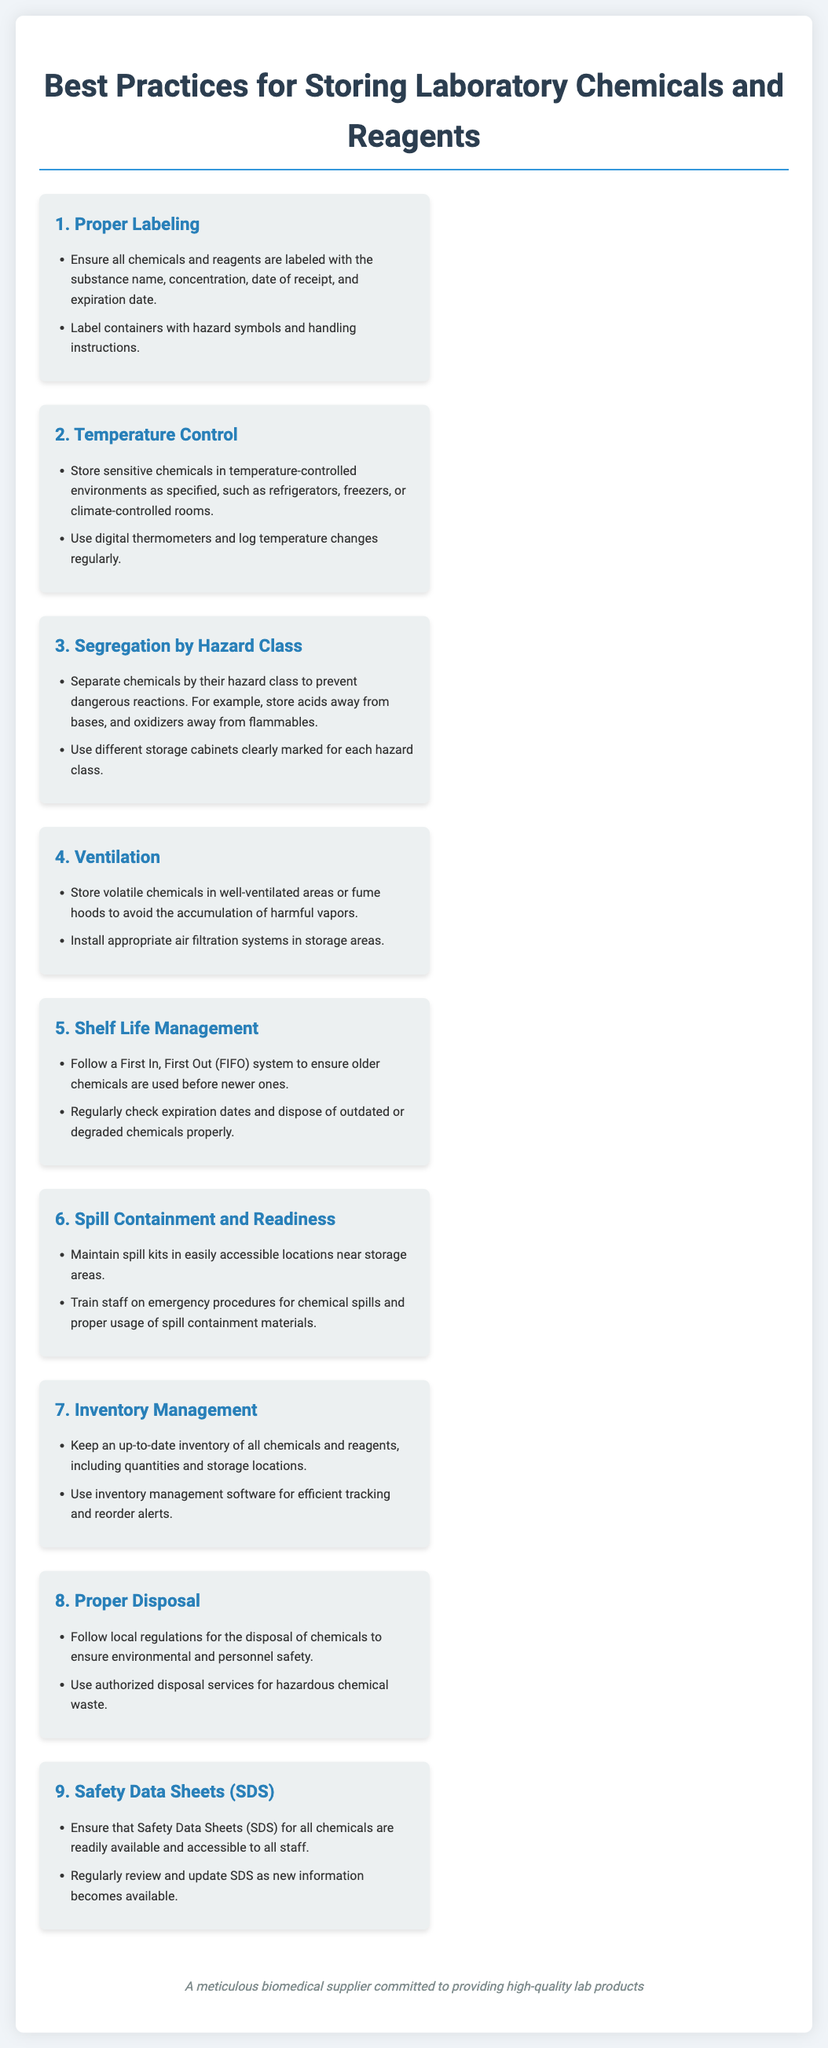What is the first best practice listed? The first best practice in the list is focused on proper labeling of chemicals and reagents.
Answer: Proper Labeling What should volatile chemicals be stored in? The document specifies that volatile chemicals should be stored in well-ventilated areas or fume hoods.
Answer: Well-ventilated areas or fume hoods How often should temperature changes be logged? The document implies that temperature changes should be logged regularly to monitor storage conditions.
Answer: Regularly What storage system is recommended for managing shelf life? The recommended system in the document for managing shelf life is the First In, First Out (FIFO) system.
Answer: First In, First Out (FIFO) Which types of chemicals should be stored separately? Chemicals should be segregated by hazard class to prevent dangerous reactions, such as acids away from bases.
Answer: Hazard class What should be available for all chemicals? The document states that Safety Data Sheets (SDS) should be readily available for all chemicals.
Answer: Safety Data Sheets (SDS) What is crucial to maintain in storage areas? The list mentions that spill kits should be maintained in easily accessible locations near storage areas.
Answer: Spill kits What should be done with outdated chemicals? The document advises to regularly check expiration dates and dispose of outdated chemicals properly.
Answer: Dispose properly What system is suggested for inventory management? The use of inventory management software is suggested for efficient tracking and reorder alerts.
Answer: Inventory management software 